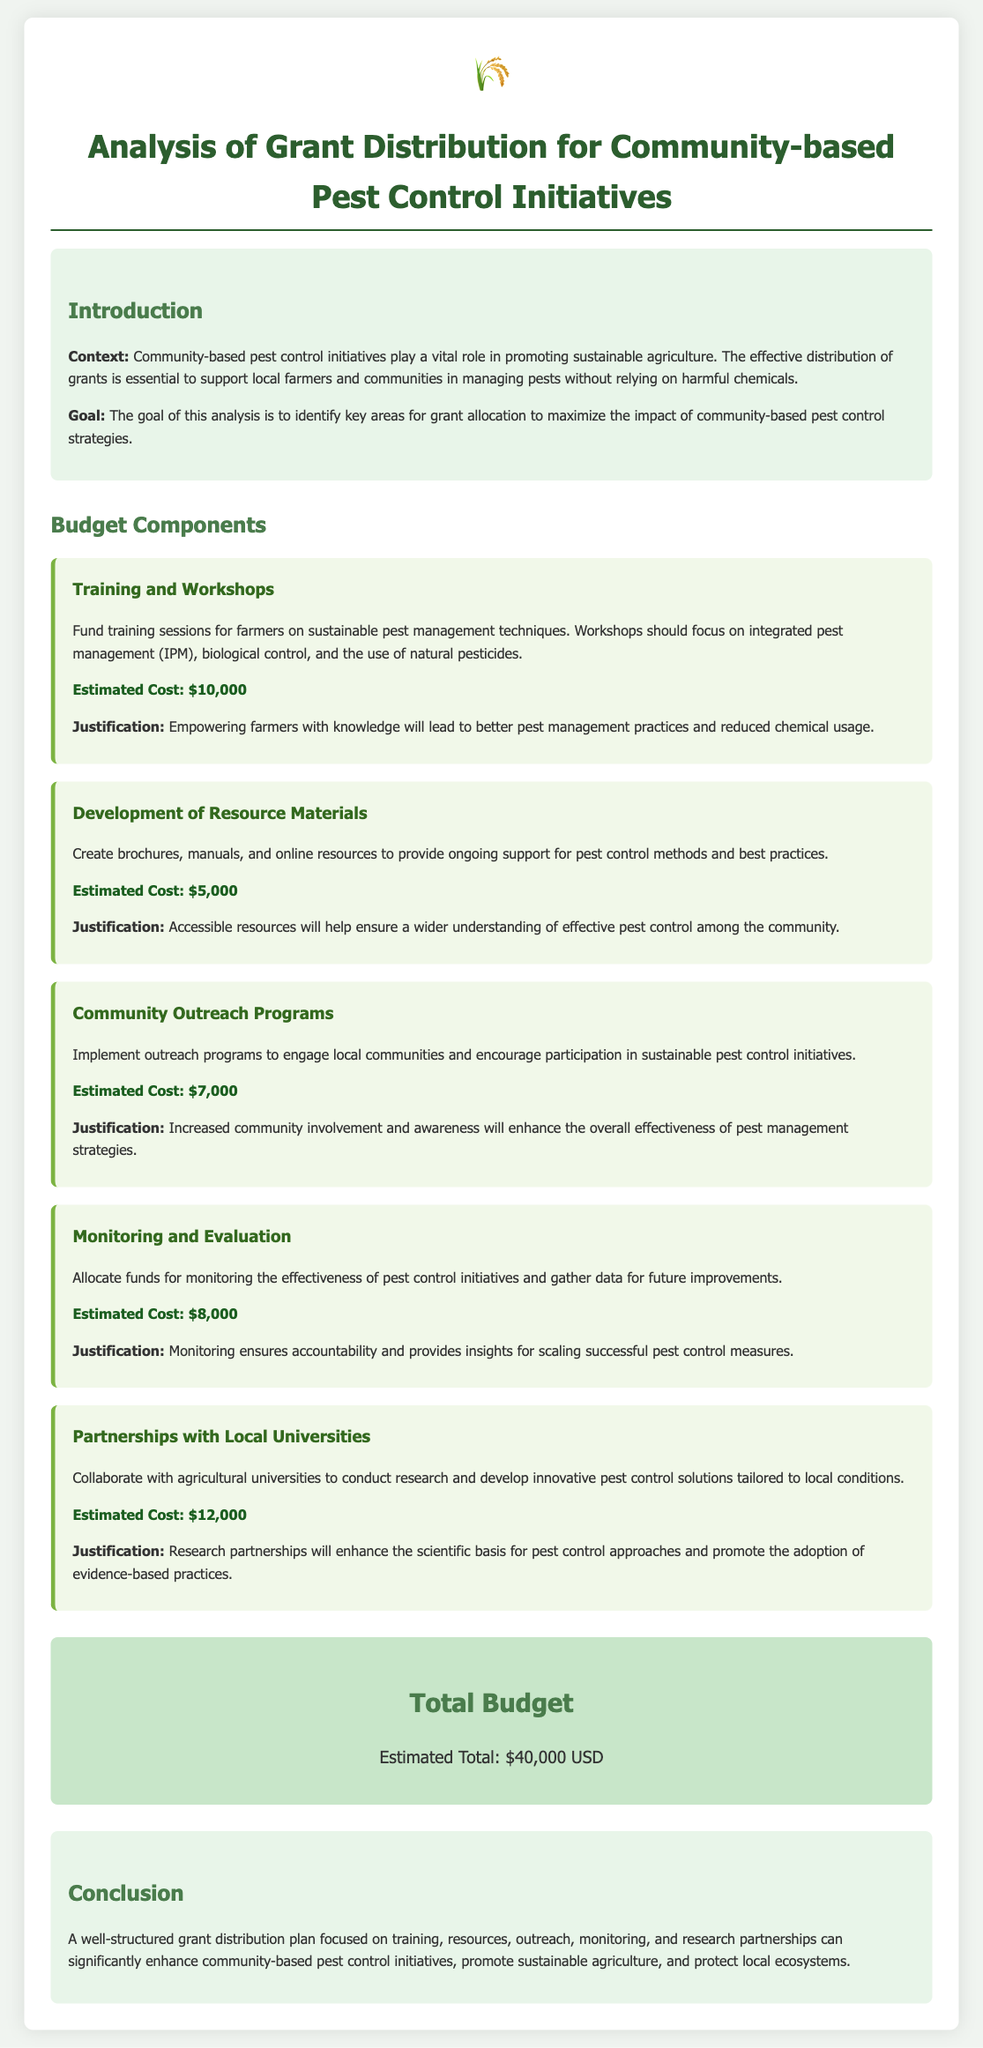what is the total budget? The total budget is presented in the document as the estimated total cost for all budget components, which is $40,000.
Answer: $40,000 what is the estimated cost for training and workshops? The estimated cost for training and workshops is specified directly under that section, amounting to $10,000.
Answer: $10,000 how much is allocated for community outreach programs? The document states that the budget for community outreach programs is $7,000, which is found in the respective component section.
Answer: $7,000 what is the justification for developing resource materials? The justification for developing resource materials is stated to help ensure a wider understanding of effective pest control.
Answer: Wider understanding of effective pest control which component has the highest estimated cost? The component with the highest estimated cost is partnerships with local universities, totaling $12,000, as noted in the budget components.
Answer: $12,000 what is the estimated cost for monitoring and evaluation? The estimated cost for monitoring and evaluation is outlined in the budget as $8,000.
Answer: $8,000 what is the main goal of the analysis? The main goal of the analysis is highlighted in the introduction, which is to identify key areas for grant allocation.
Answer: Identify key areas for grant allocation how much is allocated for developing resource materials? The allocation for developing resource materials is directly stated as $5,000 in the corresponding budget section.
Answer: $5,000 